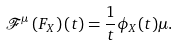Convert formula to latex. <formula><loc_0><loc_0><loc_500><loc_500>\mathcal { F } ^ { \mu } \left ( F _ { X } \right ) ( t ) = \frac { 1 } { t } \phi _ { X } ( t ) \mu .</formula> 